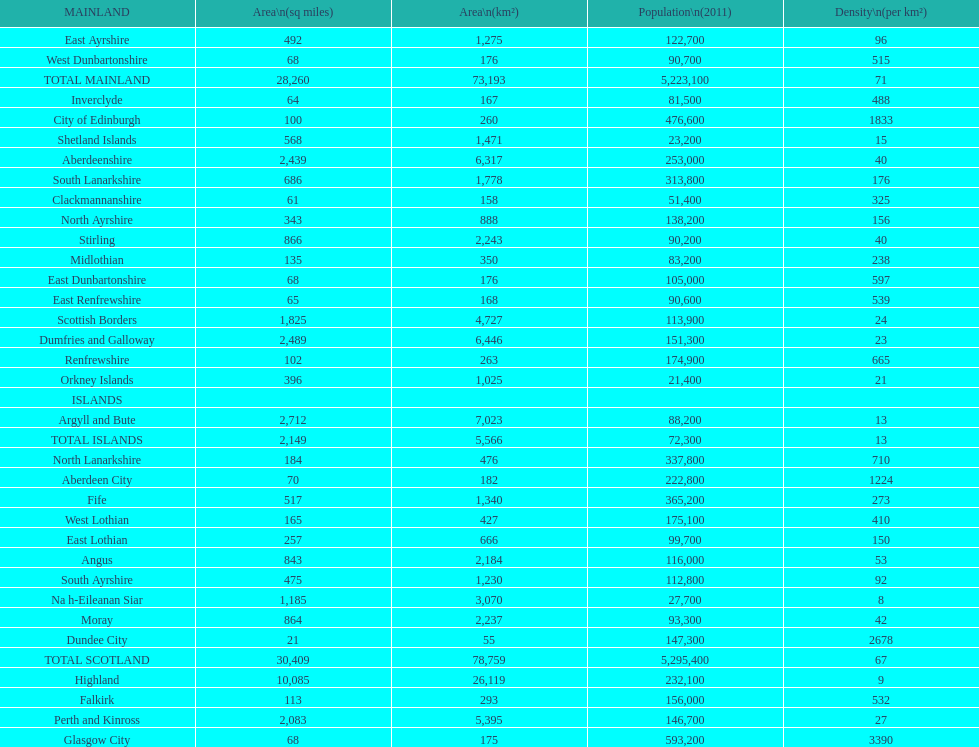What is the variation in square miles from angus to fife? 326. 